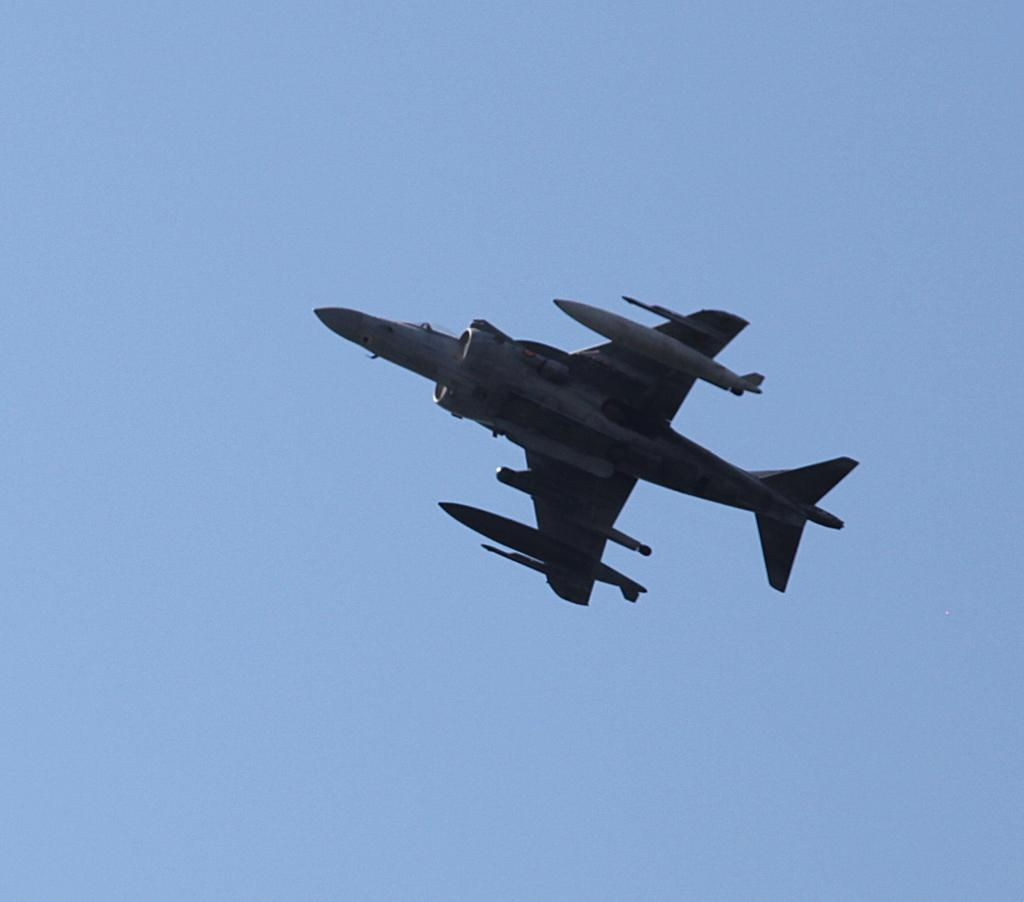What is the main subject of the image? The main subject of the image is a plane. What is the plane doing in the image? The plane is flying in the sky. What type of punishment is being given to the plane in the image? There is no punishment being given to the plane in the image; it is simply flying in the sky. What is the plane using to eat in the image? Planes do not eat, and there is no fork present in the image. 